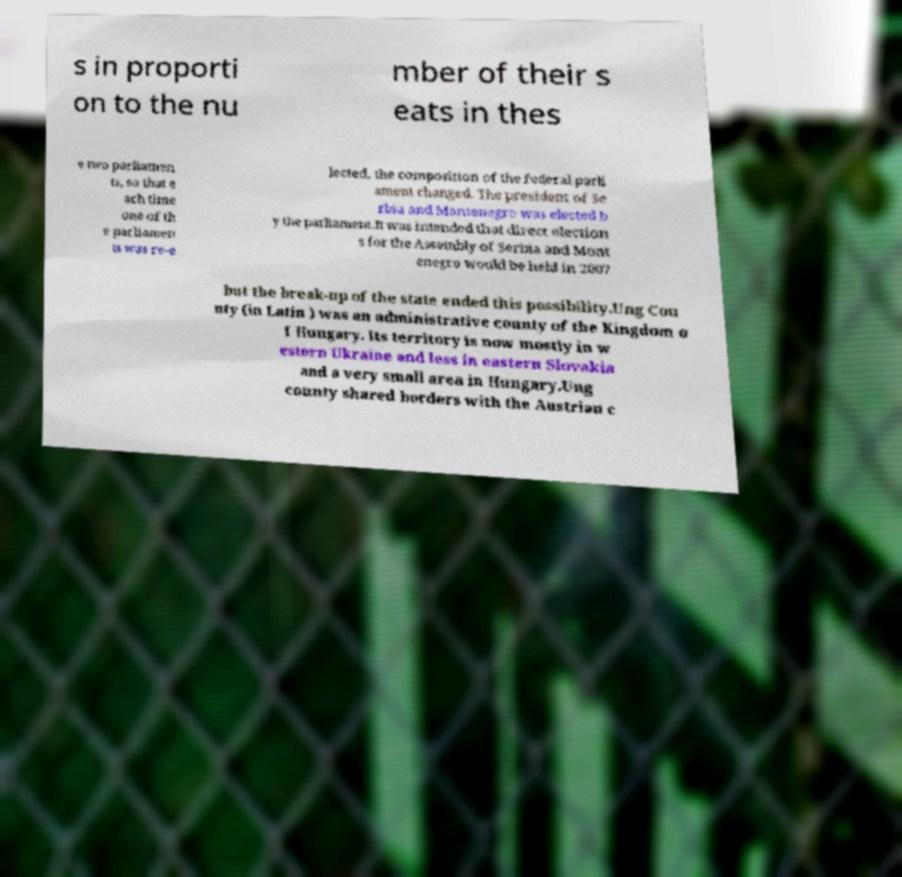Can you accurately transcribe the text from the provided image for me? s in proporti on to the nu mber of their s eats in thes e two parliamen ts, so that e ach time one of th e parliamen ts was re-e lected, the composition of the federal parli ament changed. The president of Se rbia and Montenegro was elected b y the parliament.It was intended that direct election s for the Assembly of Serbia and Mont enegro would be held in 2007 but the break-up of the state ended this possibility.Ung Cou nty (in Latin ) was an administrative county of the Kingdom o f Hungary. Its territory is now mostly in w estern Ukraine and less in eastern Slovakia and a very small area in Hungary.Ung county shared borders with the Austrian c 